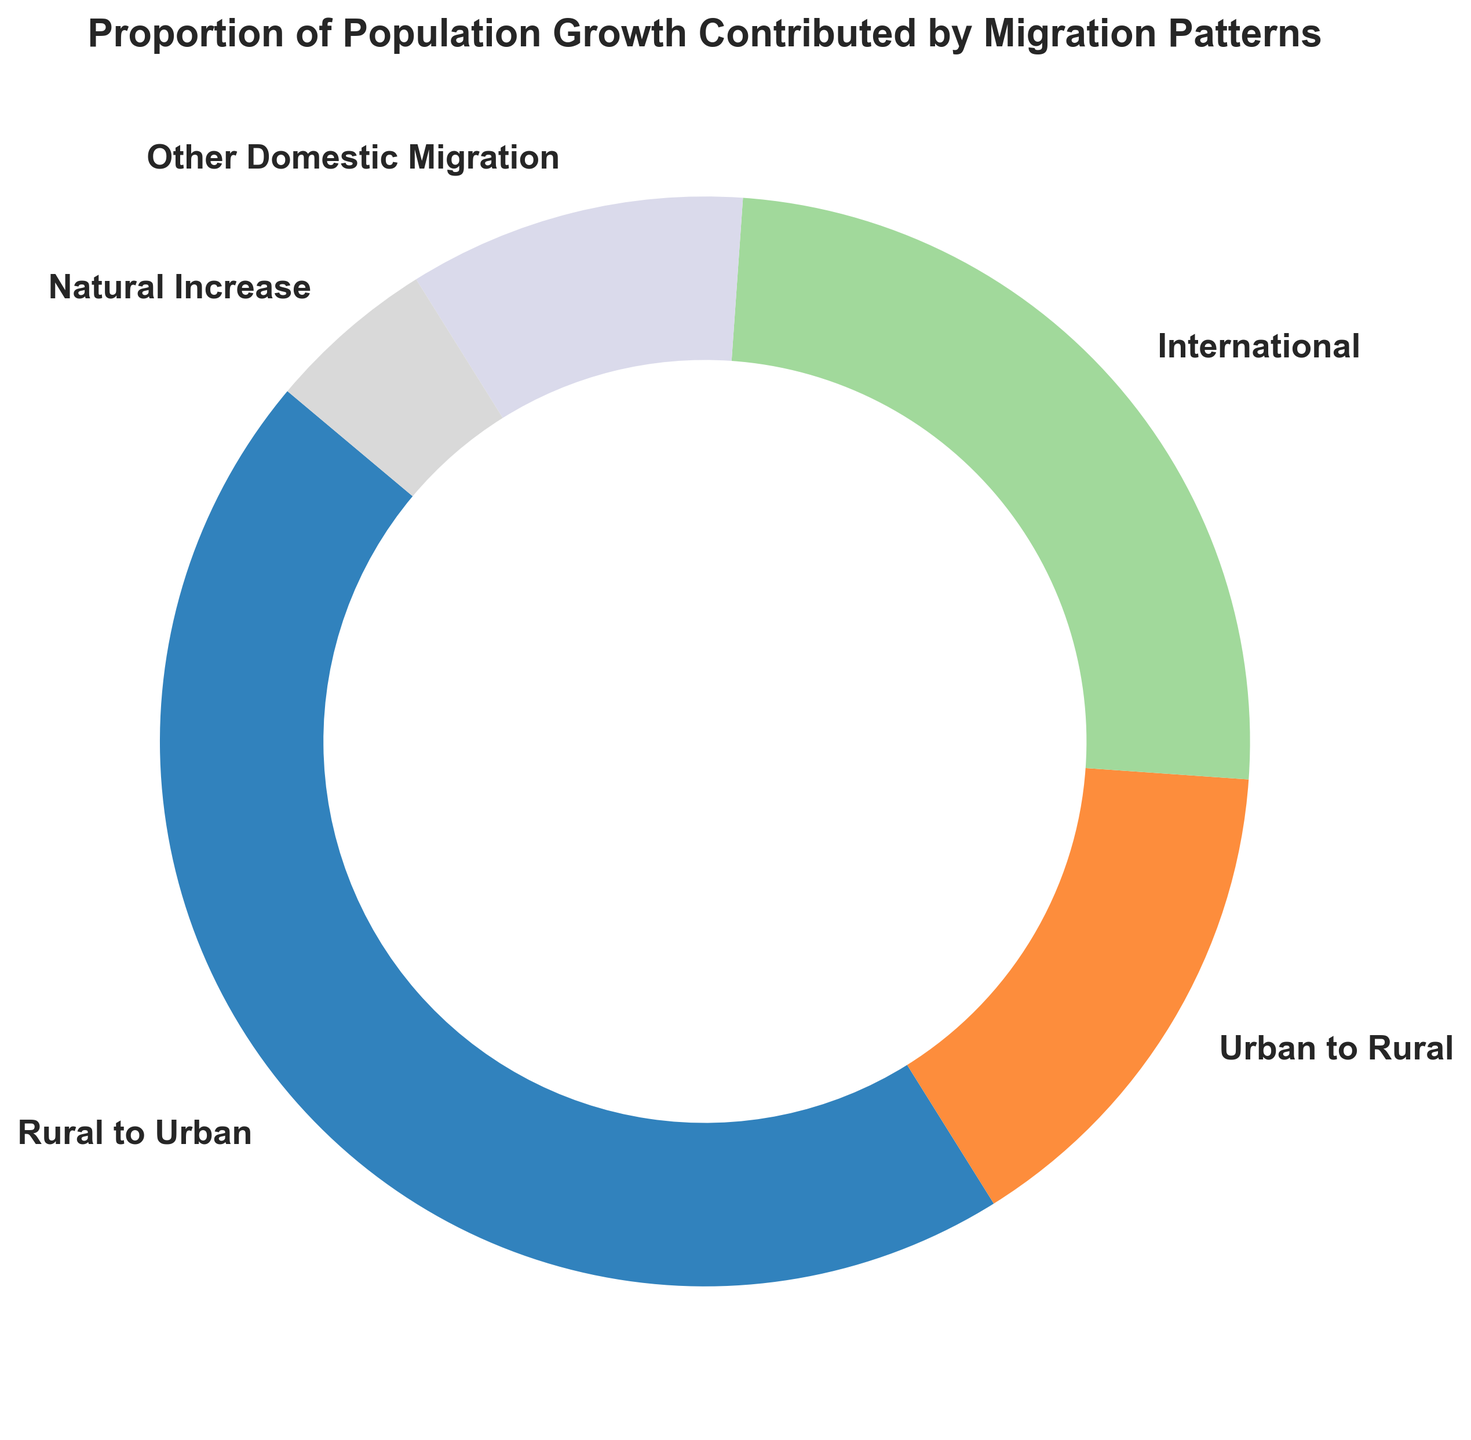What portion of the population growth is due to Rural to Urban migration? By looking at the figure, identify the segment labeled "Rural to Urban" and check the percentage value indicated beside it.
Answer: 45% Which migration pattern contributes the least to population growth? Observe all the segments and compare the percentage values. The segment with the smallest percentage represents the pattern with the least contribution.
Answer: Natural Increase How much more does Rural to Urban migration contribute to population growth compared to Urban to Rural migration? Find the percentage values for both "Rural to Urban" (45%) and "Urban to Rural" (15%). Subtract the latter from the former: 45% - 15% = 30%.
Answer: 30% What is the total contribution of international and other domestic migrations together? Locate the segments for "International" (25%) and "Other Domestic Migration" (10%). Add these percentages: 25% + 10% = 35%.
Answer: 35% Which migration pattern comes immediately after Rural to Urban in terms of its contribution? Identify the segment for "Rural to Urban." Check which segment follows it in decreasing order of percentage.
Answer: International How does the contribution of International migration compare to Other Domestic Migration? Compare the segments for "International" (25%) and "Other Domestic Migration" (10%). Determine which is larger.
Answer: International contributes more Is the combined proportion of Urban to Rural and Natural Increase greater than the proportion of International migration? Find the sum of "Urban to Rural" (15%) and "Natural Increase" (5%): 15% + 5% = 20%. Compare this 20% with "International" (25%).
Answer: No What is the visual color of the segment representing Other Domestic Migration? Identify the segment labeled "Other Domestic Migration" and describe its color.
Answer: Varies (it will depend on the color palette used) What is the difference in the percentage of population growth between Rural to Urban migration and the sum of Urban to Rural and Other Domestic Migration? Calculate the sum of "Urban to Rural" (15%) and "Other Domestic Migration" (10%): 15% + 10% = 25%. Subtract this from "Rural to Urban" (45% - 25% = 20%).
Answer: 20% Which segments' combined contributions form exactly half of the population growth? Identify segments whose percentages sum up to 50%. For example, "Rural to Urban" (45%) and part of "Urban to Rural" (5%).
Answer: Rural to Urban and part of Urban to Rural 